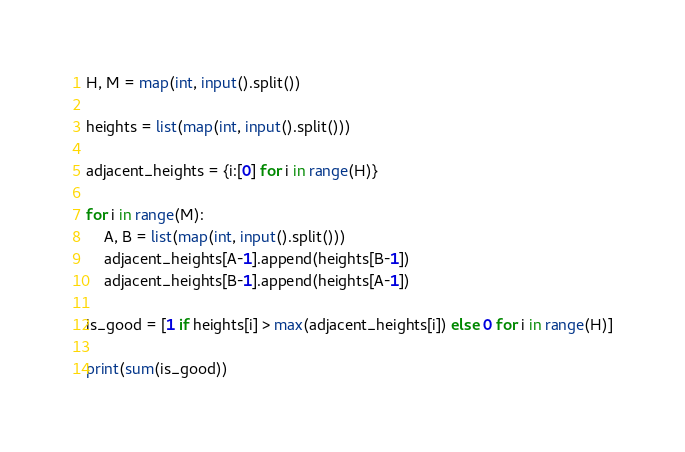<code> <loc_0><loc_0><loc_500><loc_500><_Python_>H, M = map(int, input().split())

heights = list(map(int, input().split()))

adjacent_heights = {i:[0] for i in range(H)}

for i in range(M):
    A, B = list(map(int, input().split()))
    adjacent_heights[A-1].append(heights[B-1])
    adjacent_heights[B-1].append(heights[A-1])

is_good = [1 if heights[i] > max(adjacent_heights[i]) else 0 for i in range(H)]

print(sum(is_good))</code> 